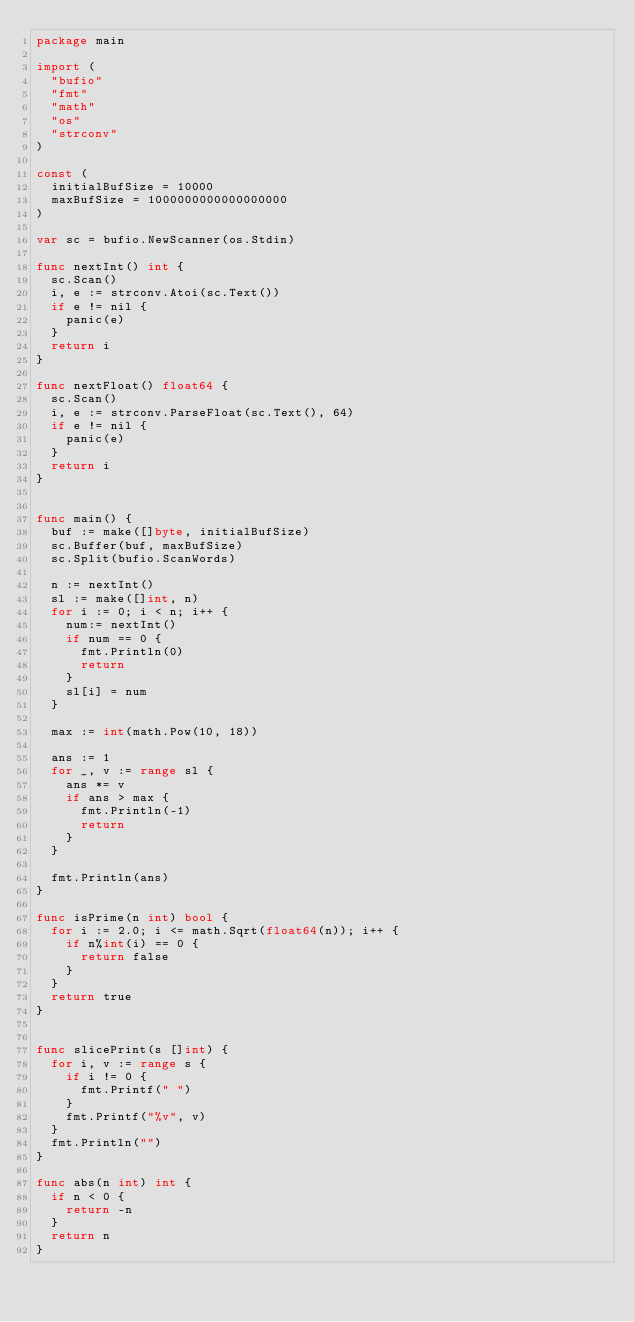<code> <loc_0><loc_0><loc_500><loc_500><_Go_>package main

import (
	"bufio"
	"fmt"
	"math"
	"os"
	"strconv"
)

const (
	initialBufSize = 10000
	maxBufSize = 1000000000000000000
)

var sc = bufio.NewScanner(os.Stdin)

func nextInt() int {
	sc.Scan()
	i, e := strconv.Atoi(sc.Text())
	if e != nil {
		panic(e)
	}
	return i
}

func nextFloat() float64 {
	sc.Scan()
	i, e := strconv.ParseFloat(sc.Text(), 64)
	if e != nil {
		panic(e)
	}
	return i
}


func main() {
	buf := make([]byte, initialBufSize)
	sc.Buffer(buf, maxBufSize)
	sc.Split(bufio.ScanWords)

	n := nextInt()
	sl := make([]int, n)
	for i := 0; i < n; i++ {
		num:= nextInt()
		if num == 0 {
			fmt.Println(0)
			return
		}
		sl[i] = num
	}

  max := int(math.Pow(10, 18))

	ans := 1
	for _, v := range sl {
		ans *= v
		if ans > max {
			fmt.Println(-1)
			return
		}
	}

	fmt.Println(ans)
}

func isPrime(n int) bool {
	for i := 2.0; i <= math.Sqrt(float64(n)); i++ {
		if n%int(i) == 0 {
			return false
		}
	}
	return true
}


func slicePrint(s []int) {
	for i, v := range s {
		if i != 0 {
			fmt.Printf(" ")
		}
		fmt.Printf("%v", v)
	}
	fmt.Println("")
}

func abs(n int) int {
	if n < 0 {
		return -n
	}
	return n
}
</code> 